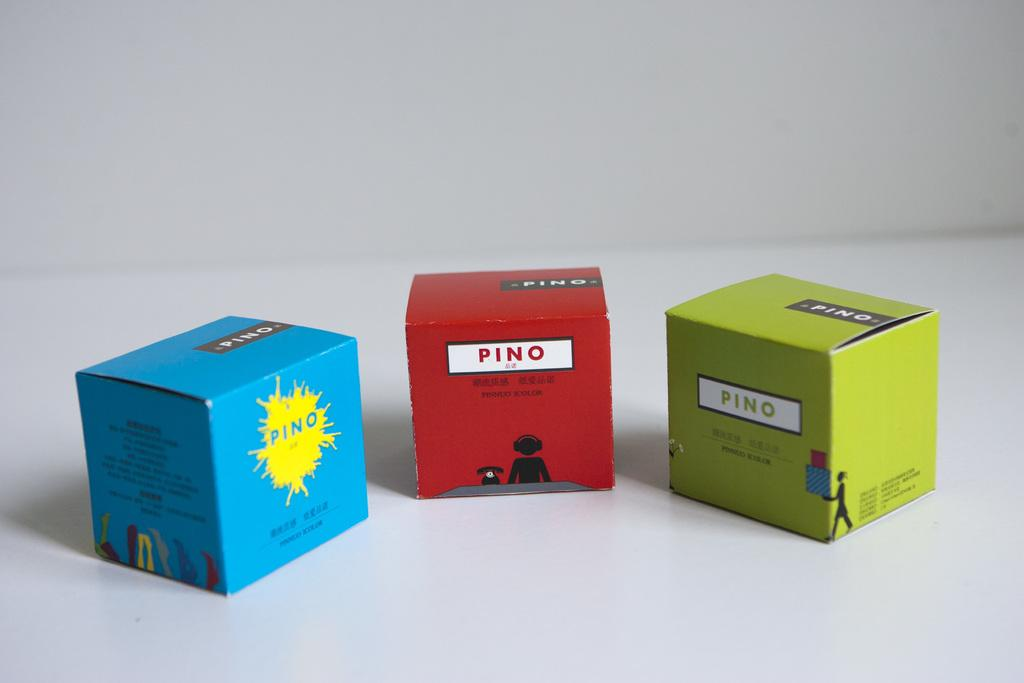What type of images are on the boxes in the image? There are cartoon pictures on the boxes in the image. What color is the background of the image? The background of the image is white. How much jam is in the cartoon character's mouth in the image? There is no cartoon character with jam in their mouth in the image. The image only features cartoon pictures on the boxes. 